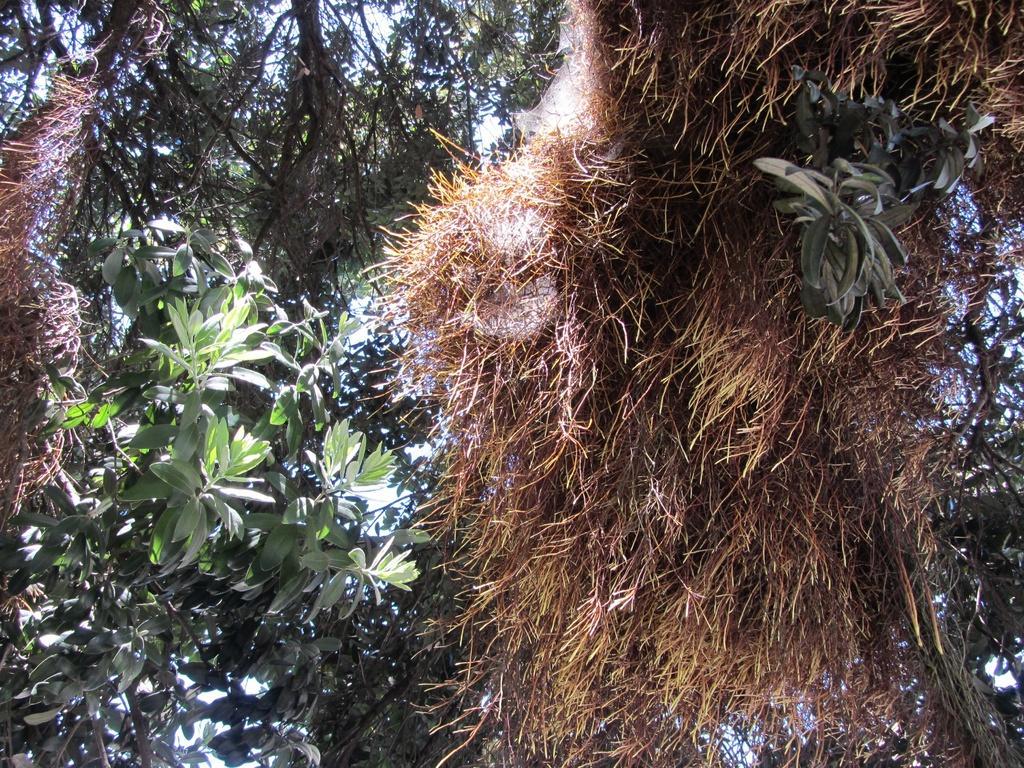In one or two sentences, can you explain what this image depicts? In the center of the image we can see the sky, trees, grass and a few other objects. 